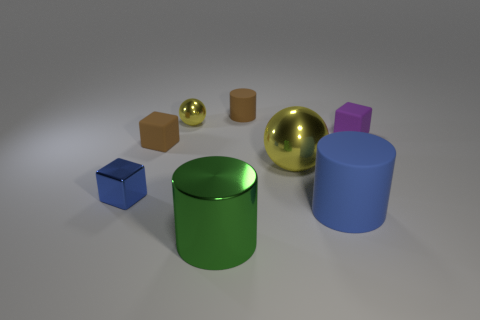Subtract all purple blocks. How many blocks are left? 2 Subtract all matte cylinders. How many cylinders are left? 1 Subtract all green cubes. How many blue cylinders are left? 1 Add 2 small brown things. How many objects exist? 10 Subtract 1 brown blocks. How many objects are left? 7 Subtract all cubes. How many objects are left? 5 Subtract 1 cubes. How many cubes are left? 2 Subtract all blue balls. Subtract all green cylinders. How many balls are left? 2 Subtract all blue matte cylinders. Subtract all tiny yellow objects. How many objects are left? 6 Add 5 blue matte things. How many blue matte things are left? 6 